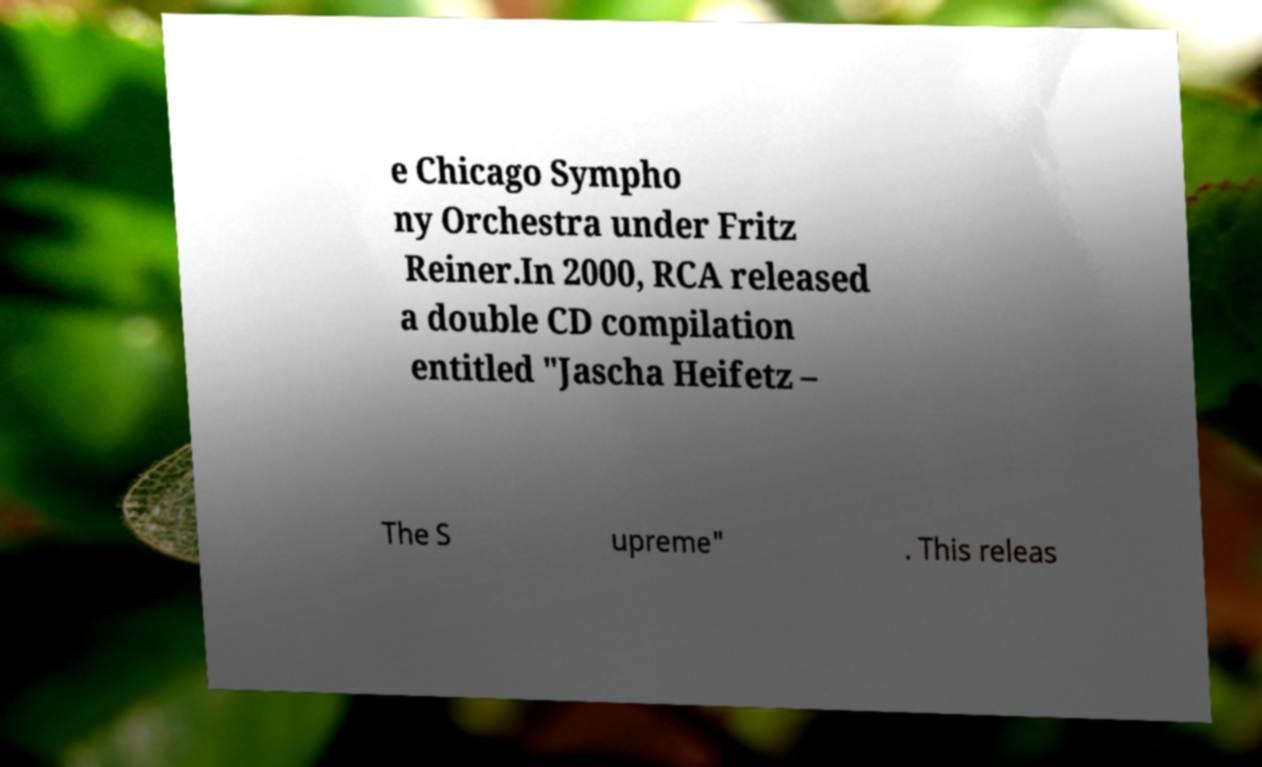Can you accurately transcribe the text from the provided image for me? e Chicago Sympho ny Orchestra under Fritz Reiner.In 2000, RCA released a double CD compilation entitled "Jascha Heifetz – The S upreme" . This releas 